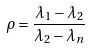<formula> <loc_0><loc_0><loc_500><loc_500>\rho = { \frac { \lambda _ { 1 } - \lambda _ { 2 } } { \lambda _ { 2 } - \lambda _ { n } } }</formula> 